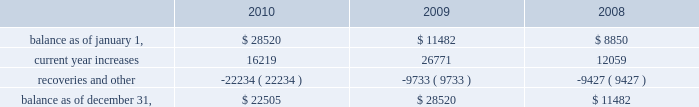American tower corporation and subsidiaries notes to consolidated financial statements recognizing customer revenue , the company must assess the collectability of both the amounts billed and the portion recognized on a straight-line basis .
This assessment takes customer credit risk and business and industry conditions into consideration to ultimately determine the collectability of the amounts billed .
To the extent the amounts , based on management 2019s estimates , may not be collectible , recognition is deferred until such point as the uncertainty is resolved .
Any amounts which were previously recognized as revenue and subsequently determined to be uncollectible are charged to bad debt expense .
Accounts receivable are reported net of allowances for doubtful accounts related to estimated losses resulting from a customer 2019s inability to make required payments and reserves for amounts invoiced whose collectability is not reasonably assured .
These allowances are generally estimated based on payment patterns , days past due and collection history , and incorporate changes in economic conditions that may not be reflected in historical trends , such as customers in bankruptcy , liquidation or reorganization .
Receivables are written-off against the allowances when they are determined uncollectible .
Such determination includes analysis and consideration of the particular conditions of the account .
Changes in the allowances were as follows for the years ended december 31 , ( in thousands ) : .
The company 2019s largest international customer is iusacell , which is the brand name under which a group of companies controlled by grupo iusacell , s.a .
De c.v .
( 201cgrupo iusacell 201d ) operates .
Iusacell represented approximately 4% ( 4 % ) of the company 2019s total revenue for the year ended december 31 , 2010 .
Grupo iusacell has been engaged in a refinancing of a majority of its u.s .
Dollar denominated debt , and in connection with this process , two of the legal entities of the group , including grupo iusacell , voluntarily filed for a pre-packaged concurso mercantil ( a process substantially equivalent to chapter 11 of u.s .
Bankruptcy law ) with the backing of a majority of their financial creditors in december 2010 .
As of december 31 , 2010 , iusacell notes receivable , net , and related assets ( which include financing lease commitments and a deferred rent asset that are primarily long-term in nature ) were $ 19.7 million and $ 51.2 million , respectively .
Functional currency 2014as a result of changes to the organizational structure of the company 2019s subsidiaries in latin america in 2010 , the company determined that effective january 1 , 2010 , the functional currency of its foreign subsidiary in brazil is the brazilian real .
From that point forward , all assets and liabilities held by the subsidiary in brazil are translated into u.s .
Dollars at the exchange rate in effect at the end of the applicable reporting period .
Revenues and expenses are translated at the average monthly exchange rates and the cumulative translation effect is included in stockholders 2019 equity .
The change in functional currency from u.s .
Dollars to brazilian real gave rise to an increase in the net value of certain non-monetary assets and liabilities .
The aggregate impact on such assets and liabilities was $ 39.8 million with an offsetting increase in accumulated other comprehensive income ( loss ) .
As a result of the renegotiation of the company 2019s agreements with its largest international customer , iusacell , which included , among other changes , converting all of iusacell 2019s contractual obligations to the company from u.s .
Dollars to mexican pesos , the company has determined that effective april 1 , 2010 , the functional currency of certain of its foreign subsidiaries in mexico is the mexican peso .
From that point forward , all assets and liabilities held by those subsidiaries in mexico are translated into u.s .
Dollars at the exchange rate in effect at the end of the applicable reporting period .
Revenues and expenses are translated at the average monthly exchange rates and the cumulative translation effect is included in stockholders 2019 equity .
The change in functional .
In 2009 what was the percentage change in the allowance balance for the uncollectable accounts? 
Computations: ((28520 - 11482) / 11482)
Answer: 1.48389. American tower corporation and subsidiaries notes to consolidated financial statements recognizing customer revenue , the company must assess the collectability of both the amounts billed and the portion recognized on a straight-line basis .
This assessment takes customer credit risk and business and industry conditions into consideration to ultimately determine the collectability of the amounts billed .
To the extent the amounts , based on management 2019s estimates , may not be collectible , recognition is deferred until such point as the uncertainty is resolved .
Any amounts which were previously recognized as revenue and subsequently determined to be uncollectible are charged to bad debt expense .
Accounts receivable are reported net of allowances for doubtful accounts related to estimated losses resulting from a customer 2019s inability to make required payments and reserves for amounts invoiced whose collectability is not reasonably assured .
These allowances are generally estimated based on payment patterns , days past due and collection history , and incorporate changes in economic conditions that may not be reflected in historical trends , such as customers in bankruptcy , liquidation or reorganization .
Receivables are written-off against the allowances when they are determined uncollectible .
Such determination includes analysis and consideration of the particular conditions of the account .
Changes in the allowances were as follows for the years ended december 31 , ( in thousands ) : .
The company 2019s largest international customer is iusacell , which is the brand name under which a group of companies controlled by grupo iusacell , s.a .
De c.v .
( 201cgrupo iusacell 201d ) operates .
Iusacell represented approximately 4% ( 4 % ) of the company 2019s total revenue for the year ended december 31 , 2010 .
Grupo iusacell has been engaged in a refinancing of a majority of its u.s .
Dollar denominated debt , and in connection with this process , two of the legal entities of the group , including grupo iusacell , voluntarily filed for a pre-packaged concurso mercantil ( a process substantially equivalent to chapter 11 of u.s .
Bankruptcy law ) with the backing of a majority of their financial creditors in december 2010 .
As of december 31 , 2010 , iusacell notes receivable , net , and related assets ( which include financing lease commitments and a deferred rent asset that are primarily long-term in nature ) were $ 19.7 million and $ 51.2 million , respectively .
Functional currency 2014as a result of changes to the organizational structure of the company 2019s subsidiaries in latin america in 2010 , the company determined that effective january 1 , 2010 , the functional currency of its foreign subsidiary in brazil is the brazilian real .
From that point forward , all assets and liabilities held by the subsidiary in brazil are translated into u.s .
Dollars at the exchange rate in effect at the end of the applicable reporting period .
Revenues and expenses are translated at the average monthly exchange rates and the cumulative translation effect is included in stockholders 2019 equity .
The change in functional currency from u.s .
Dollars to brazilian real gave rise to an increase in the net value of certain non-monetary assets and liabilities .
The aggregate impact on such assets and liabilities was $ 39.8 million with an offsetting increase in accumulated other comprehensive income ( loss ) .
As a result of the renegotiation of the company 2019s agreements with its largest international customer , iusacell , which included , among other changes , converting all of iusacell 2019s contractual obligations to the company from u.s .
Dollars to mexican pesos , the company has determined that effective april 1 , 2010 , the functional currency of certain of its foreign subsidiaries in mexico is the mexican peso .
From that point forward , all assets and liabilities held by those subsidiaries in mexico are translated into u.s .
Dollars at the exchange rate in effect at the end of the applicable reporting period .
Revenues and expenses are translated at the average monthly exchange rates and the cumulative translation effect is included in stockholders 2019 equity .
The change in functional .
In 2010 what was the ratio of the notes receivable , net , to the related assets \\n? 
Computations: (19.7 / 51.2)
Answer: 0.38477. 